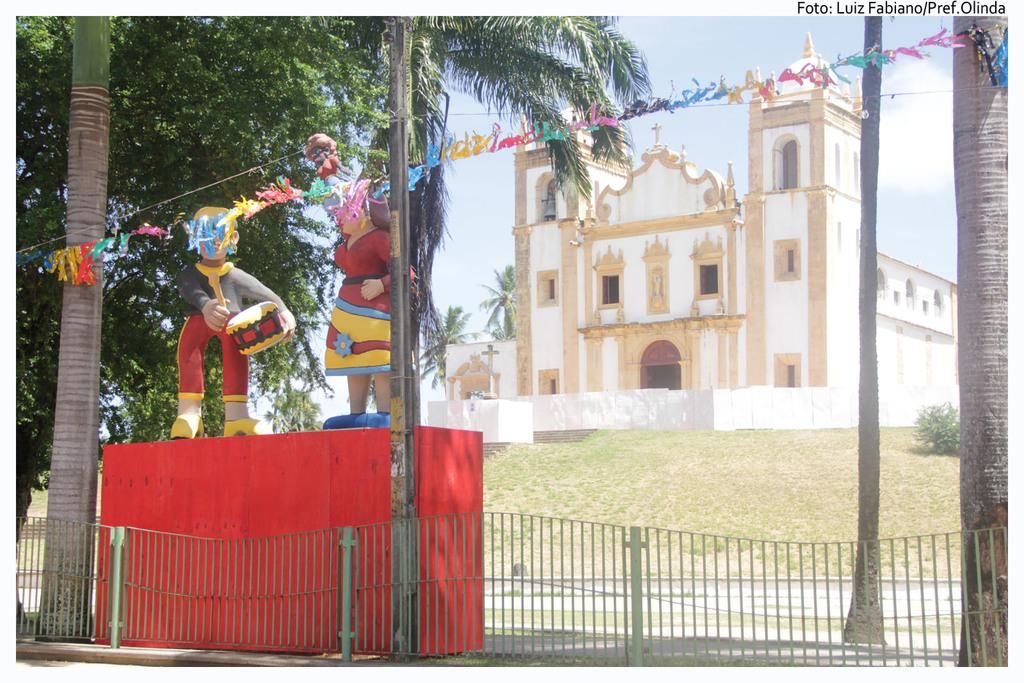What color is the prominent object in the image? There is a red object in the image. What is on the red object? There are statues on the red object. What type of vegetation can be seen in the image? There are trees, grass, and a plant in the image. What can be seen in the background of the image? There is a building and the sky visible in the background of the image. What type of pig can be seen playing with the statues on the red object? There is no pig present in the image; the red object has statues on it, but no pig is visible. 